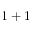Convert formula to latex. <formula><loc_0><loc_0><loc_500><loc_500>1 + 1</formula> 